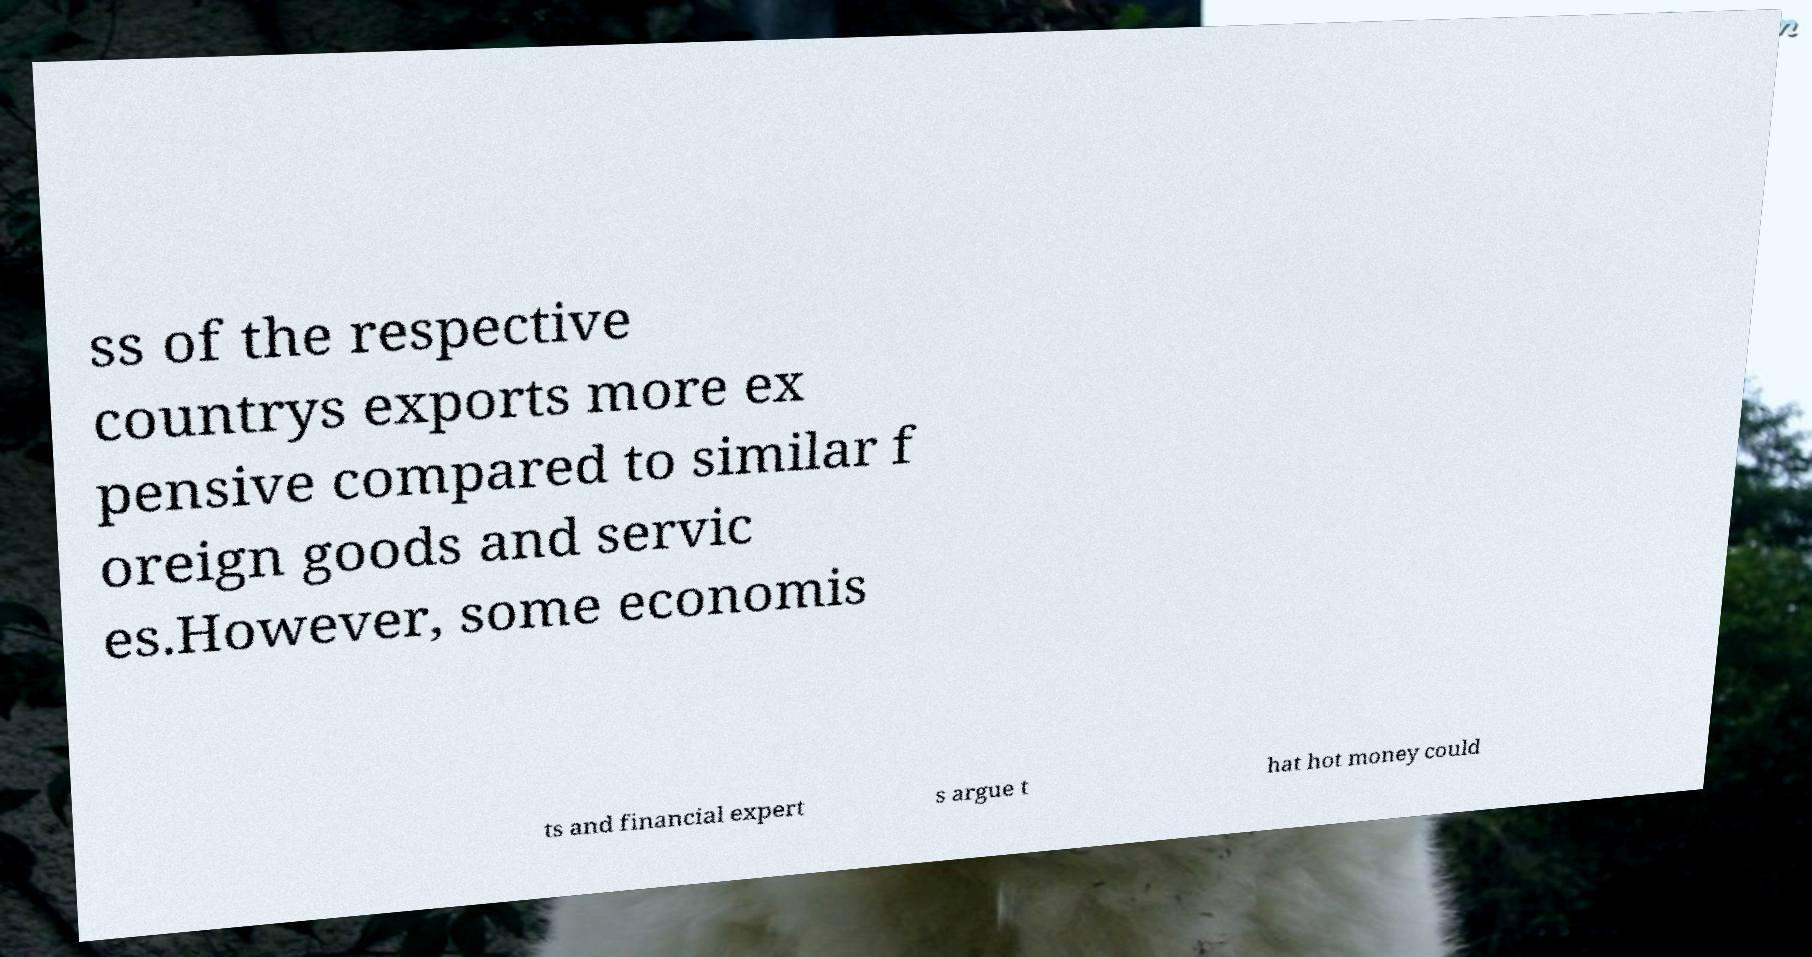There's text embedded in this image that I need extracted. Can you transcribe it verbatim? ss of the respective countrys exports more ex pensive compared to similar f oreign goods and servic es.However, some economis ts and financial expert s argue t hat hot money could 